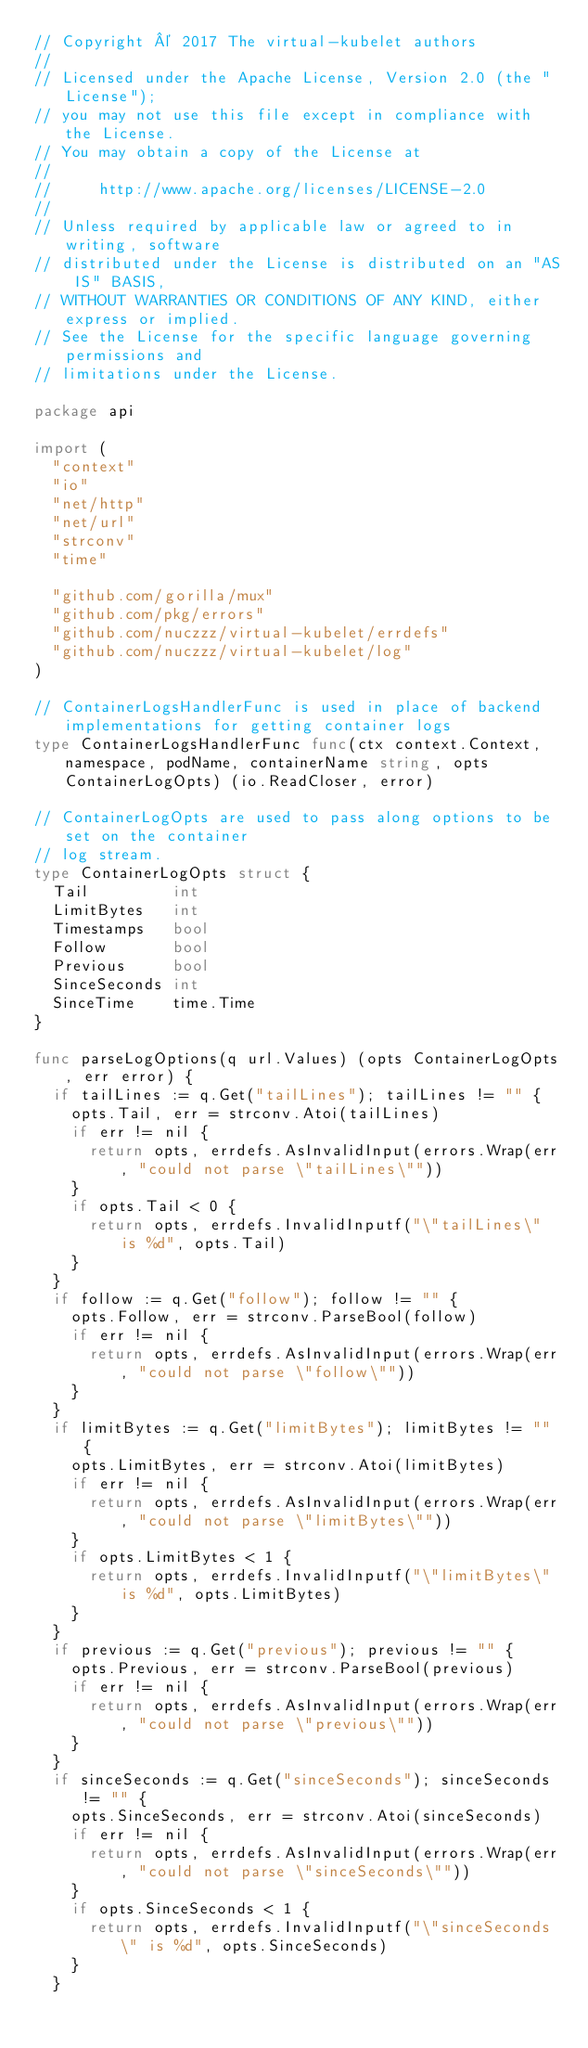<code> <loc_0><loc_0><loc_500><loc_500><_Go_>// Copyright © 2017 The virtual-kubelet authors
//
// Licensed under the Apache License, Version 2.0 (the "License");
// you may not use this file except in compliance with the License.
// You may obtain a copy of the License at
//
//     http://www.apache.org/licenses/LICENSE-2.0
//
// Unless required by applicable law or agreed to in writing, software
// distributed under the License is distributed on an "AS IS" BASIS,
// WITHOUT WARRANTIES OR CONDITIONS OF ANY KIND, either express or implied.
// See the License for the specific language governing permissions and
// limitations under the License.

package api

import (
	"context"
	"io"
	"net/http"
	"net/url"
	"strconv"
	"time"

	"github.com/gorilla/mux"
	"github.com/pkg/errors"
	"github.com/nuczzz/virtual-kubelet/errdefs"
	"github.com/nuczzz/virtual-kubelet/log"
)

// ContainerLogsHandlerFunc is used in place of backend implementations for getting container logs
type ContainerLogsHandlerFunc func(ctx context.Context, namespace, podName, containerName string, opts ContainerLogOpts) (io.ReadCloser, error)

// ContainerLogOpts are used to pass along options to be set on the container
// log stream.
type ContainerLogOpts struct {
	Tail         int
	LimitBytes   int
	Timestamps   bool
	Follow       bool
	Previous     bool
	SinceSeconds int
	SinceTime    time.Time
}

func parseLogOptions(q url.Values) (opts ContainerLogOpts, err error) {
	if tailLines := q.Get("tailLines"); tailLines != "" {
		opts.Tail, err = strconv.Atoi(tailLines)
		if err != nil {
			return opts, errdefs.AsInvalidInput(errors.Wrap(err, "could not parse \"tailLines\""))
		}
		if opts.Tail < 0 {
			return opts, errdefs.InvalidInputf("\"tailLines\" is %d", opts.Tail)
		}
	}
	if follow := q.Get("follow"); follow != "" {
		opts.Follow, err = strconv.ParseBool(follow)
		if err != nil {
			return opts, errdefs.AsInvalidInput(errors.Wrap(err, "could not parse \"follow\""))
		}
	}
	if limitBytes := q.Get("limitBytes"); limitBytes != "" {
		opts.LimitBytes, err = strconv.Atoi(limitBytes)
		if err != nil {
			return opts, errdefs.AsInvalidInput(errors.Wrap(err, "could not parse \"limitBytes\""))
		}
		if opts.LimitBytes < 1 {
			return opts, errdefs.InvalidInputf("\"limitBytes\" is %d", opts.LimitBytes)
		}
	}
	if previous := q.Get("previous"); previous != "" {
		opts.Previous, err = strconv.ParseBool(previous)
		if err != nil {
			return opts, errdefs.AsInvalidInput(errors.Wrap(err, "could not parse \"previous\""))
		}
	}
	if sinceSeconds := q.Get("sinceSeconds"); sinceSeconds != "" {
		opts.SinceSeconds, err = strconv.Atoi(sinceSeconds)
		if err != nil {
			return opts, errdefs.AsInvalidInput(errors.Wrap(err, "could not parse \"sinceSeconds\""))
		}
		if opts.SinceSeconds < 1 {
			return opts, errdefs.InvalidInputf("\"sinceSeconds\" is %d", opts.SinceSeconds)
		}
	}</code> 